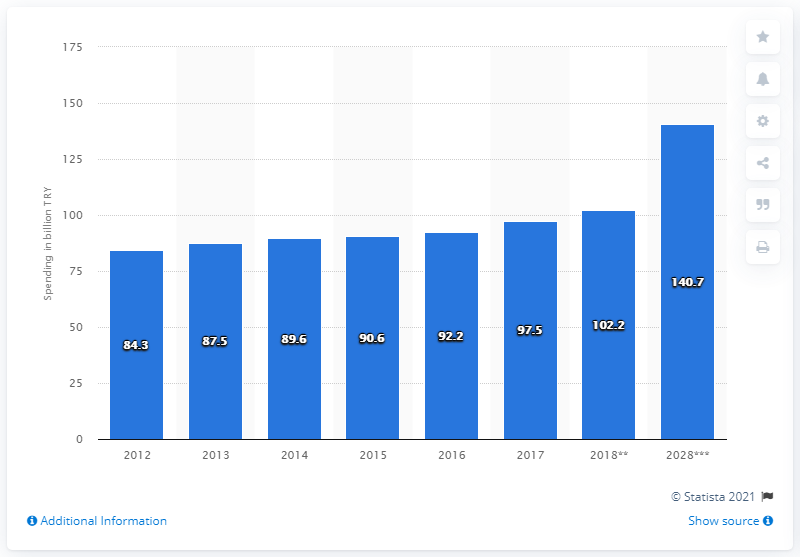Highlight a few significant elements in this photo. In 2017, Turkey spent approximately 97.5 Turkish Lira. 